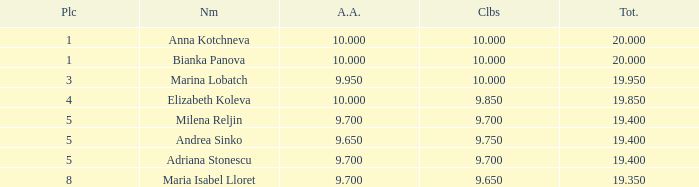What is the highest total that has andrea sinko as the name, with an all around greater than 9.65? None. 